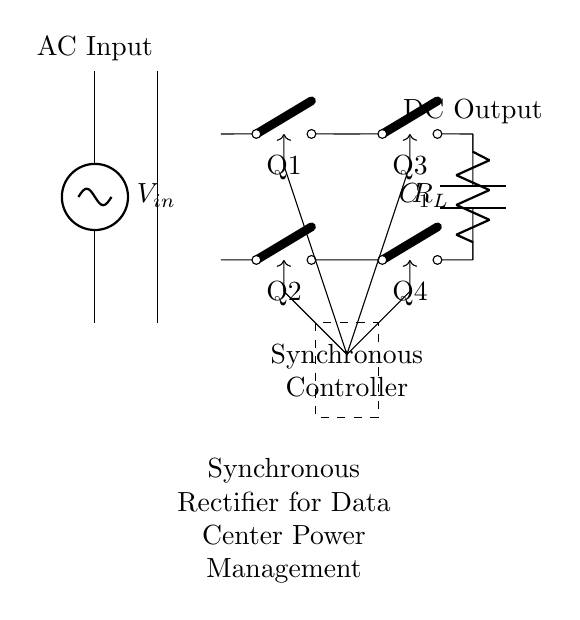What type of rectifier is used in this circuit? The circuit uses a synchronous rectifier, which is indicated by the presence of multiple switches labeled Q1, Q2, Q3, and Q4 operating under the control of a synchronous controller.
Answer: Synchronous rectifier How many switches are present in the rectifier? The circuit diagram shows a total of four switches labeled Q1, Q2, Q3, and Q4, which are used for controlling the rectification process.
Answer: Four switches What is the main function of the controller in this circuit? The synchronous controller is responsible for controlling the switching of the transistors Q1, Q2, Q3, and Q4 to minimize voltage drop and improve conversion efficiency.
Answer: Control switching What is the purpose of the capacitor in this rectifier circuit? The capacitor labeled C1 is included for smoothing the output voltage by reducing voltage ripple after rectification, which improves the DC output quality.
Answer: Smoothing output What kind of load is connected to this rectifier circuit? The circuit has a resistive load labeled as R_L, which represents the load that the rectified DC voltage powers.
Answer: Resistive load What type of input is being converted by this rectifier? The circuit is designed to convert alternating current input, highlighted as AC Input, into direct current output.
Answer: Alternating current What is the expected output of this synchronous rectifier? This synchronous rectifier circuit is expected to output a direct current, which is indicated by the label DC Output in the schematic.
Answer: Direct current 